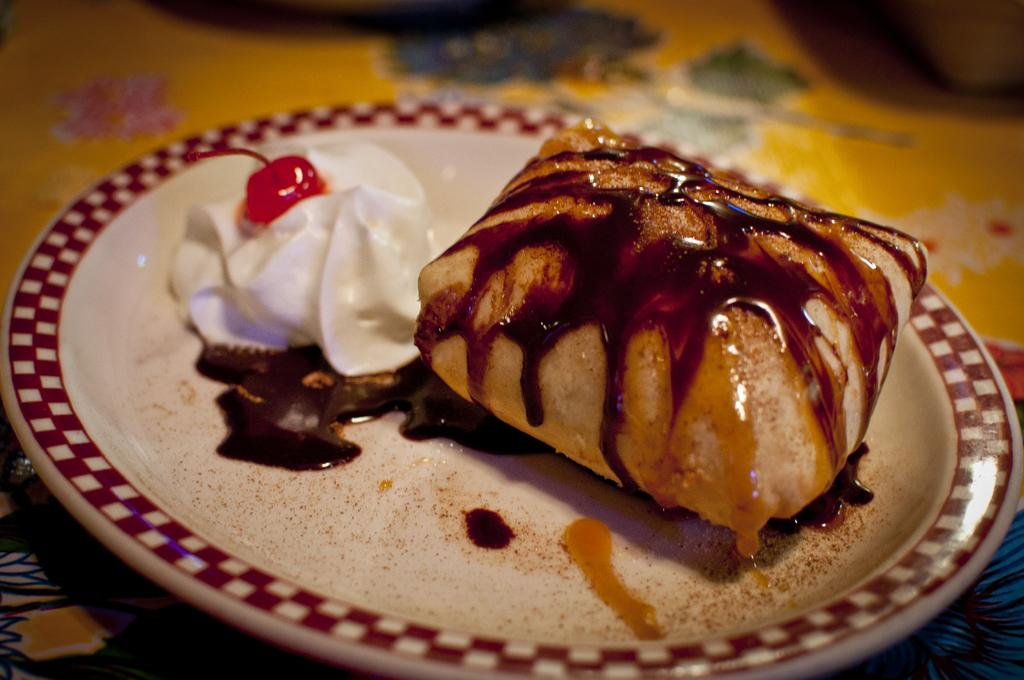What object is present on the plate in the image? There is food on the plate in the image. Can you describe the background of the image? The background of the image is blurred. What type of gold jewelry is the person wearing in the image? There is no person or gold jewelry present in the image. What is the person saying as they leave in the image? There is no person or indication of someone leaving in the image. 